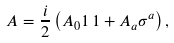Convert formula to latex. <formula><loc_0><loc_0><loc_500><loc_500>A = { \frac { i } { 2 } } \left ( A _ { 0 } 1 \, 1 + A _ { a } \sigma ^ { a } \right ) ,</formula> 